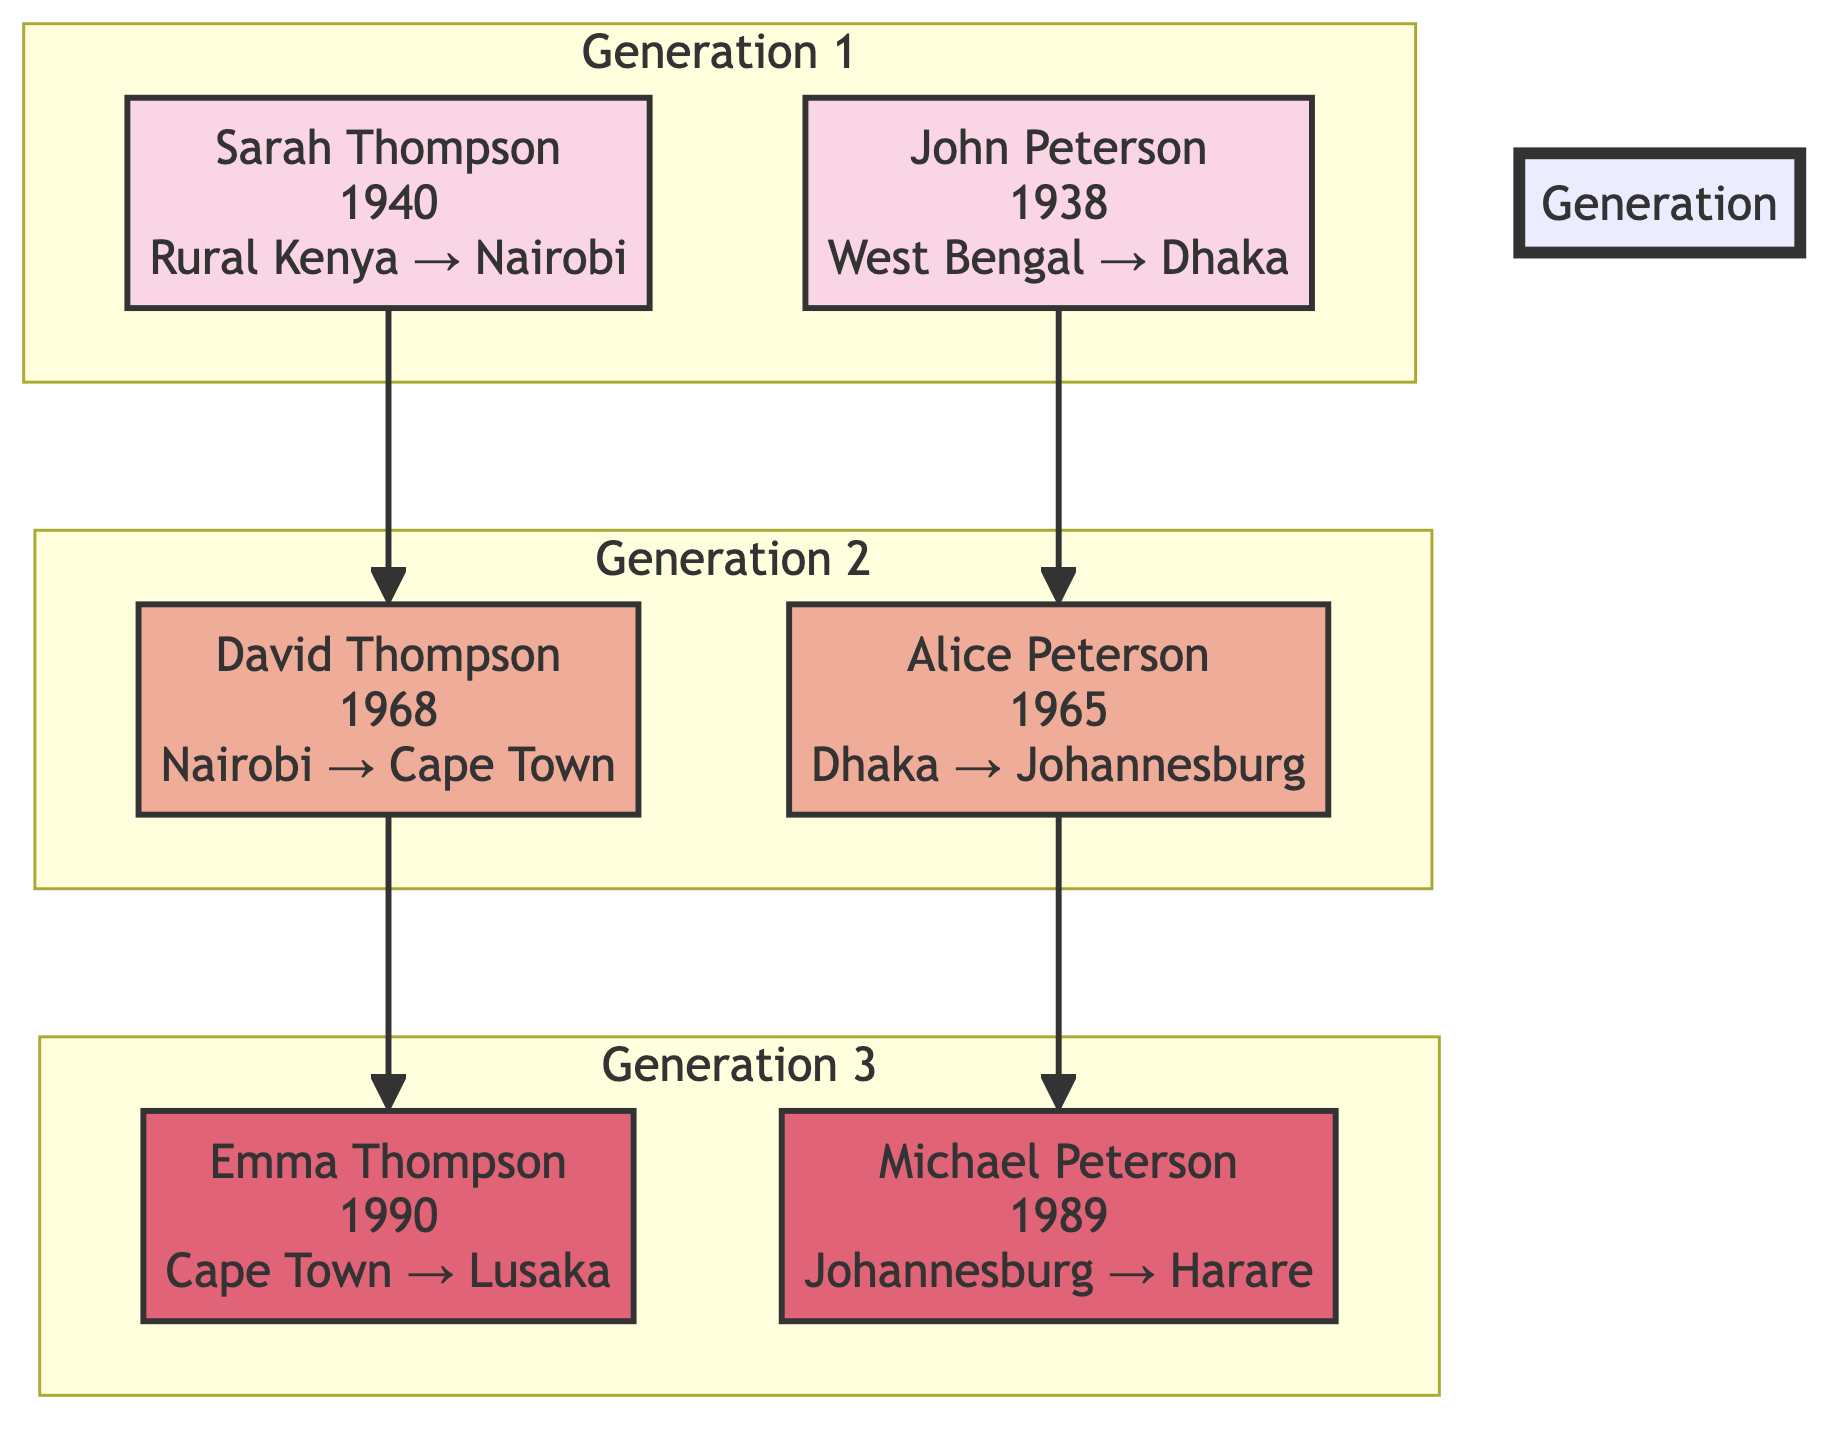What is the migration origin of Sarah Thompson? The diagram shows that Sarah Thompson was born in Rural Kenya, and indicates her migration origin is specifically that location.
Answer: Rural Kenya How many individuals are in the second generation? The diagram displays two individuals in the second generation indicated by nodes under the "Generation 2" subgraph, specifically Alice Peterson and David Thompson.
Answer: 2 Which source of water does David Thompson have access to? The diagram explicitly states that David Thompson has access to a municipal water supply, which is detailed under his individual node.
Answer: Municipal Supply What type of sanitation facility does Emma Thompson use? The diagram indicates that Emma Thompson has a septic system for sanitation, which is noted in her individual description.
Answer: Septic System Which individual migrated from Johanesburg to Harare? By examining the diagram, we see the arrow pointing from Michael Peterson showing that he is the individual who migrated from Johannesburg to Harare.
Answer: Michael Peterson Which individual has "Open Defecation" as their sanitation condition? Looking at the diagram, it is clear from John Peterson's node that he has "Open Defecation" as his sanitation condition indicated in his description.
Answer: John Peterson How many nodes are in the first generation? The visual representation in the diagram shows there are two individuals represented in the first generation (Sarah Thompson and John Peterson), indicated within the "Generation 1" subgraph.
Answer: 2 What is the relationship between Alice Peterson and David Thompson? The diagram illustrates that Alice Peterson and David Thompson belong to different migration lines, but they are first cousins, with one line descending from John Peterson and the other from Sarah Thompson.
Answer: Cousins What type of water source does Michael Peterson use? The diagram indicates that Michael Peterson has access to a municipal supply as his water source, specified in the details of his node.
Answer: Municipal Supply 